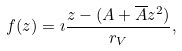Convert formula to latex. <formula><loc_0><loc_0><loc_500><loc_500>f ( z ) = \imath \frac { z - ( A + \overline { A } z ^ { 2 } ) } { r _ { V } } ,</formula> 